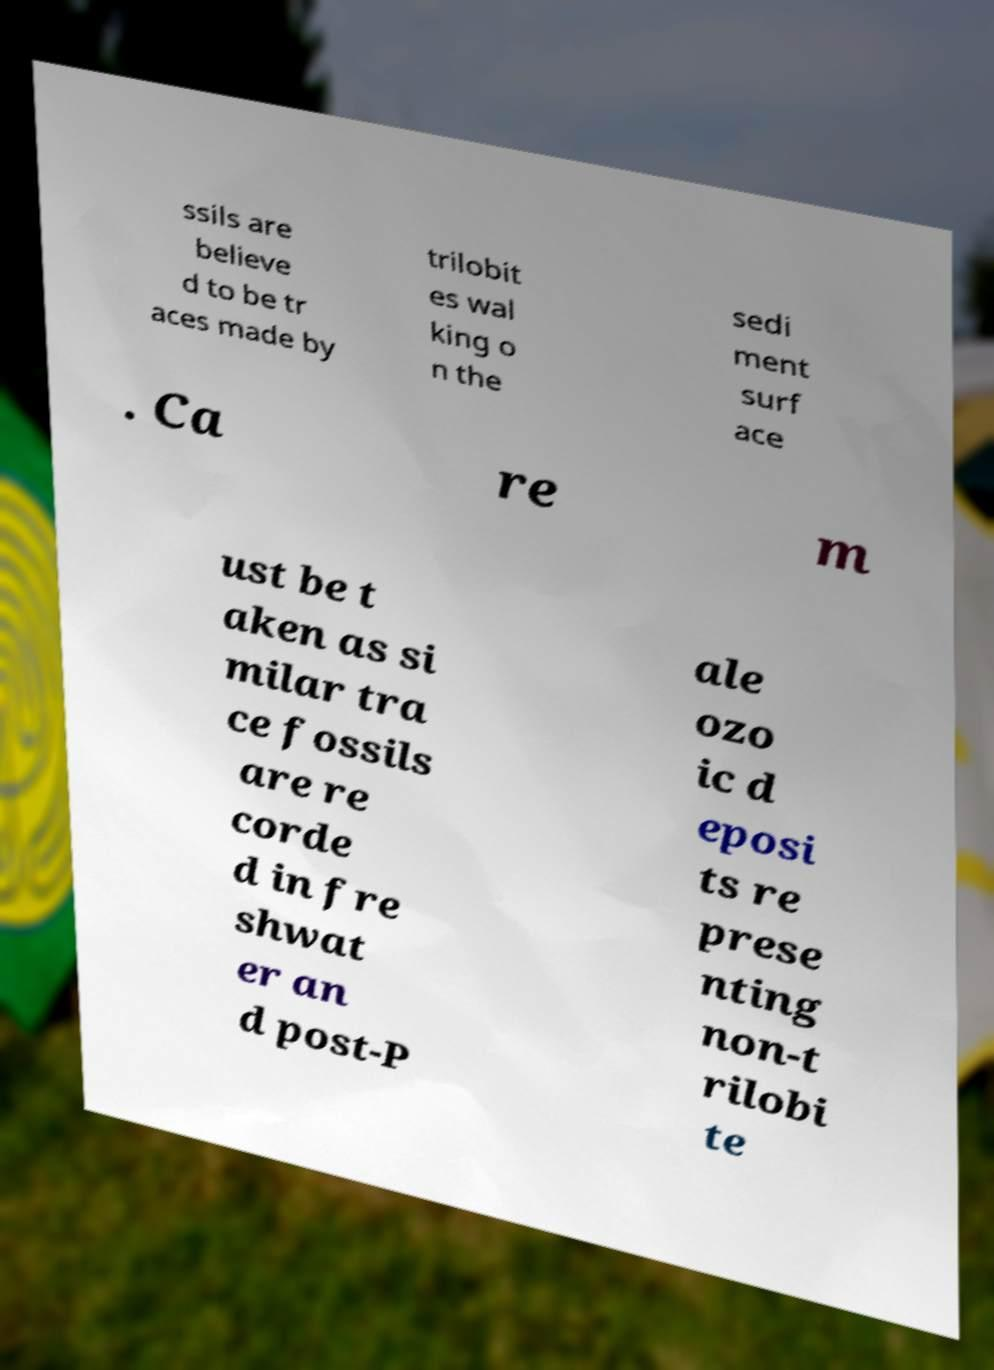For documentation purposes, I need the text within this image transcribed. Could you provide that? ssils are believe d to be tr aces made by trilobit es wal king o n the sedi ment surf ace . Ca re m ust be t aken as si milar tra ce fossils are re corde d in fre shwat er an d post-P ale ozo ic d eposi ts re prese nting non-t rilobi te 